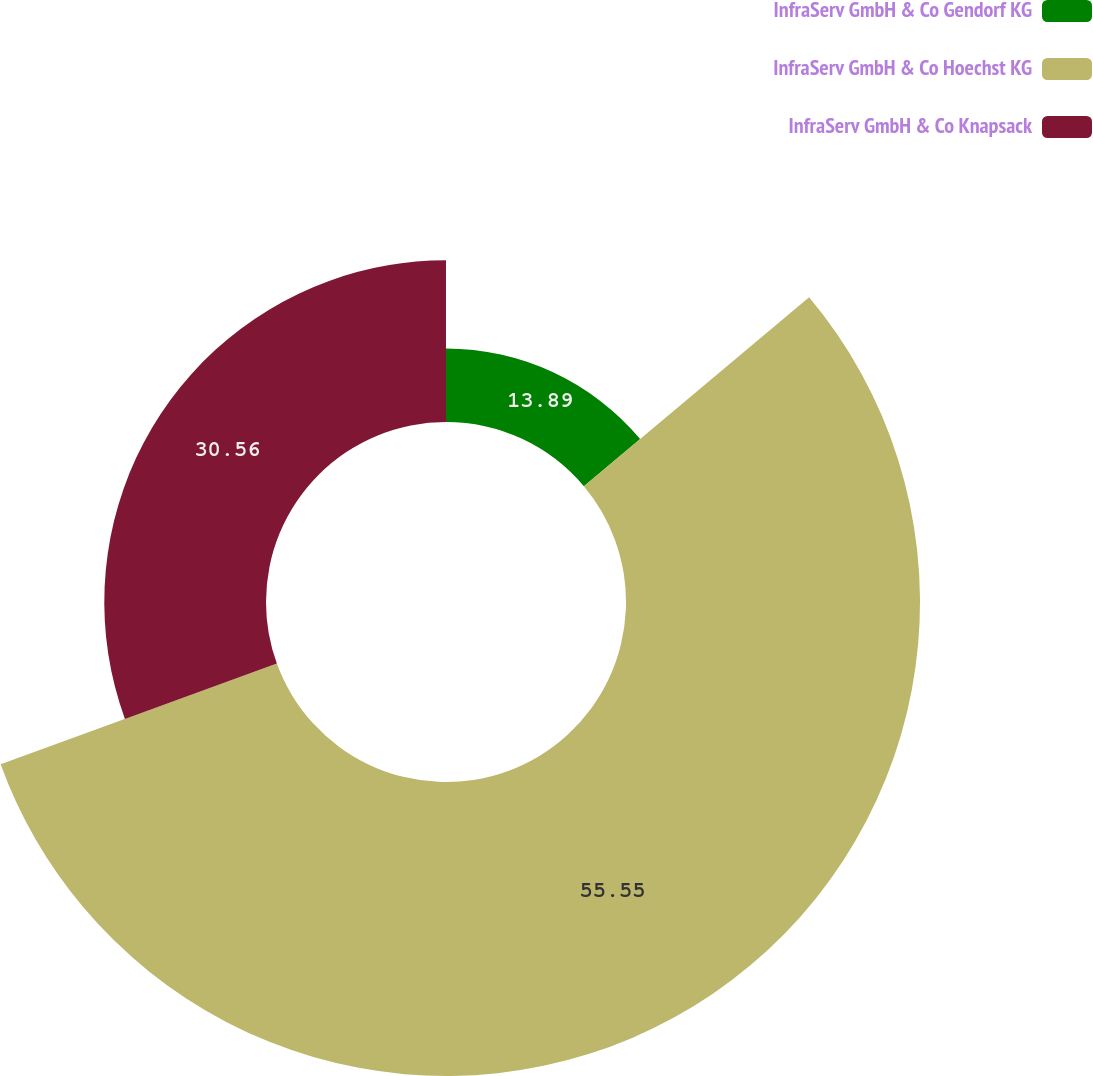Convert chart to OTSL. <chart><loc_0><loc_0><loc_500><loc_500><pie_chart><fcel>InfraServ GmbH & Co Gendorf KG<fcel>InfraServ GmbH & Co Hoechst KG<fcel>InfraServ GmbH & Co Knapsack<nl><fcel>13.89%<fcel>55.56%<fcel>30.56%<nl></chart> 